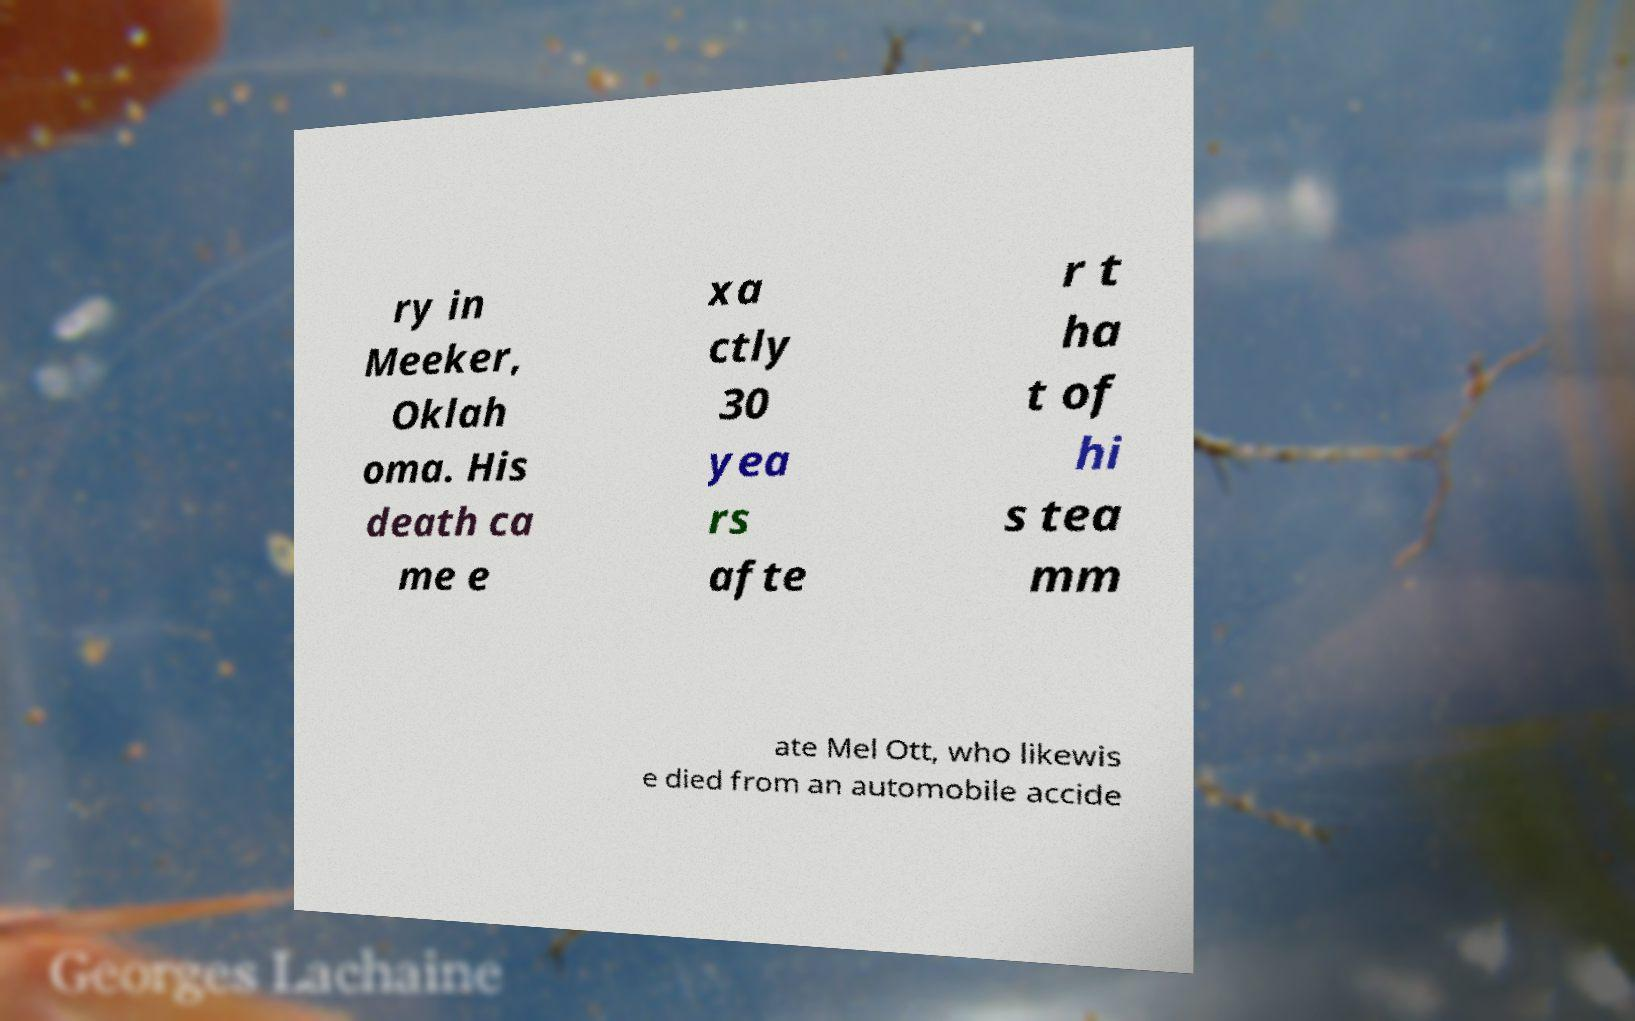Could you assist in decoding the text presented in this image and type it out clearly? ry in Meeker, Oklah oma. His death ca me e xa ctly 30 yea rs afte r t ha t of hi s tea mm ate Mel Ott, who likewis e died from an automobile accide 